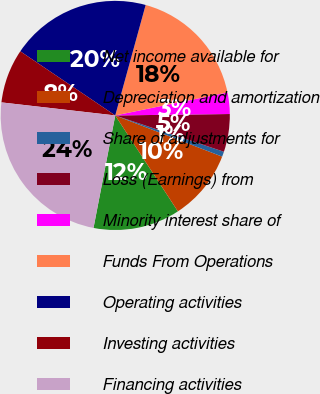<chart> <loc_0><loc_0><loc_500><loc_500><pie_chart><fcel>Net income available for<fcel>Depreciation and amortization<fcel>Share of adjustments for<fcel>Loss (Earnings) from<fcel>Minority interest share of<fcel>Funds From Operations<fcel>Operating activities<fcel>Investing activities<fcel>Financing activities<nl><fcel>12.25%<fcel>9.94%<fcel>0.72%<fcel>5.33%<fcel>3.02%<fcel>17.51%<fcel>19.82%<fcel>7.64%<fcel>23.78%<nl></chart> 